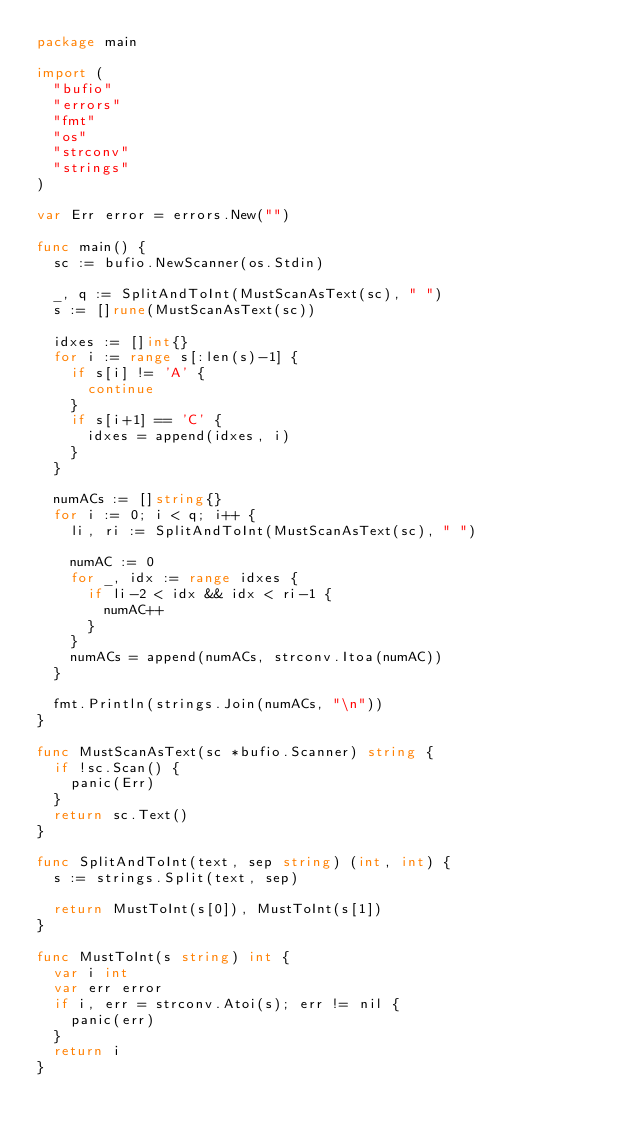<code> <loc_0><loc_0><loc_500><loc_500><_Go_>package main

import (
	"bufio"
	"errors"
	"fmt"
	"os"
	"strconv"
	"strings"
)

var Err error = errors.New("")

func main() {
	sc := bufio.NewScanner(os.Stdin)

	_, q := SplitAndToInt(MustScanAsText(sc), " ")
	s := []rune(MustScanAsText(sc))

	idxes := []int{}
	for i := range s[:len(s)-1] {
		if s[i] != 'A' {
			continue
		}
		if s[i+1] == 'C' {
			idxes = append(idxes, i)
		}
	}

	numACs := []string{}
	for i := 0; i < q; i++ {
		li, ri := SplitAndToInt(MustScanAsText(sc), " ")

		numAC := 0
		for _, idx := range idxes {
			if li-2 < idx && idx < ri-1 {
				numAC++
			}
		}
		numACs = append(numACs, strconv.Itoa(numAC))
	}

	fmt.Println(strings.Join(numACs, "\n"))
}

func MustScanAsText(sc *bufio.Scanner) string {
	if !sc.Scan() {
		panic(Err)
	}
	return sc.Text()
}

func SplitAndToInt(text, sep string) (int, int) {
	s := strings.Split(text, sep)

	return MustToInt(s[0]), MustToInt(s[1])
}

func MustToInt(s string) int {
	var i int
	var err error
	if i, err = strconv.Atoi(s); err != nil {
		panic(err)
	}
	return i
}
</code> 